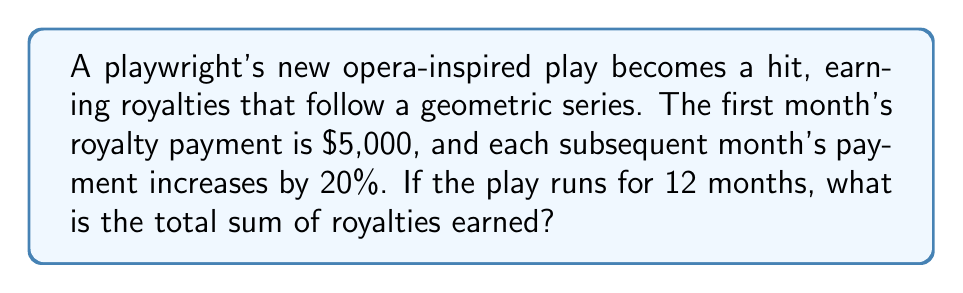Provide a solution to this math problem. Let's approach this step-by-step using the formula for the sum of a geometric series:

1) The formula for the sum of a geometric series is:
   $$S_n = \frac{a(1-r^n)}{1-r}$$
   where $a$ is the first term, $r$ is the common ratio, and $n$ is the number of terms.

2) In this case:
   $a = 5000$ (first month's royalty)
   $r = 1.20$ (20% increase each month, so 1 + 0.20 = 1.20)
   $n = 12$ (12 months)

3) Let's substitute these values into our formula:
   $$S_{12} = \frac{5000(1-1.20^{12})}{1-1.20}$$

4) Simplify the numerator:
   $1.20^{12} \approx 8.9161$
   $$S_{12} = \frac{5000(1-8.9161)}{-0.20}$$

5) Simplify further:
   $$S_{12} = \frac{5000(-7.9161)}{-0.20}$$

6) Calculate the final result:
   $$S_{12} = 197,902.50$$

Therefore, the total sum of royalties earned over 12 months is $197,902.50.
Answer: $197,902.50 